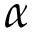Convert formula to latex. <formula><loc_0><loc_0><loc_500><loc_500>\alpha</formula> 